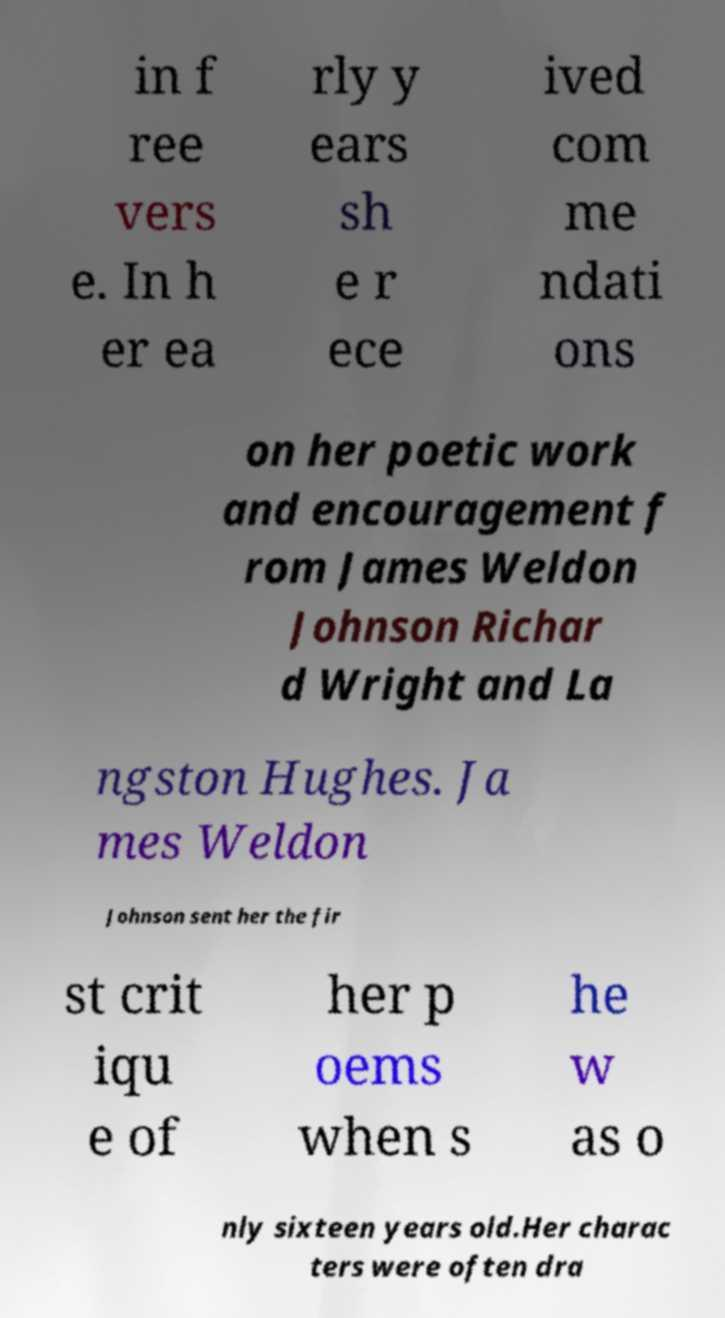There's text embedded in this image that I need extracted. Can you transcribe it verbatim? in f ree vers e. In h er ea rly y ears sh e r ece ived com me ndati ons on her poetic work and encouragement f rom James Weldon Johnson Richar d Wright and La ngston Hughes. Ja mes Weldon Johnson sent her the fir st crit iqu e of her p oems when s he w as o nly sixteen years old.Her charac ters were often dra 